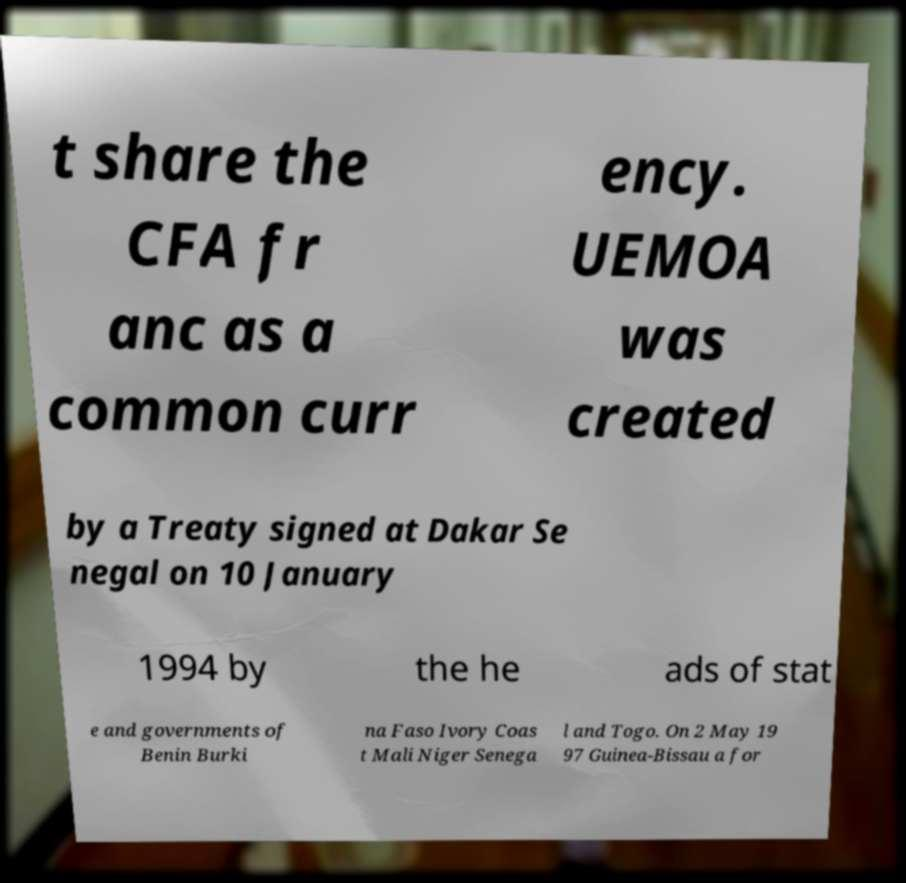Please read and relay the text visible in this image. What does it say? t share the CFA fr anc as a common curr ency. UEMOA was created by a Treaty signed at Dakar Se negal on 10 January 1994 by the he ads of stat e and governments of Benin Burki na Faso Ivory Coas t Mali Niger Senega l and Togo. On 2 May 19 97 Guinea-Bissau a for 